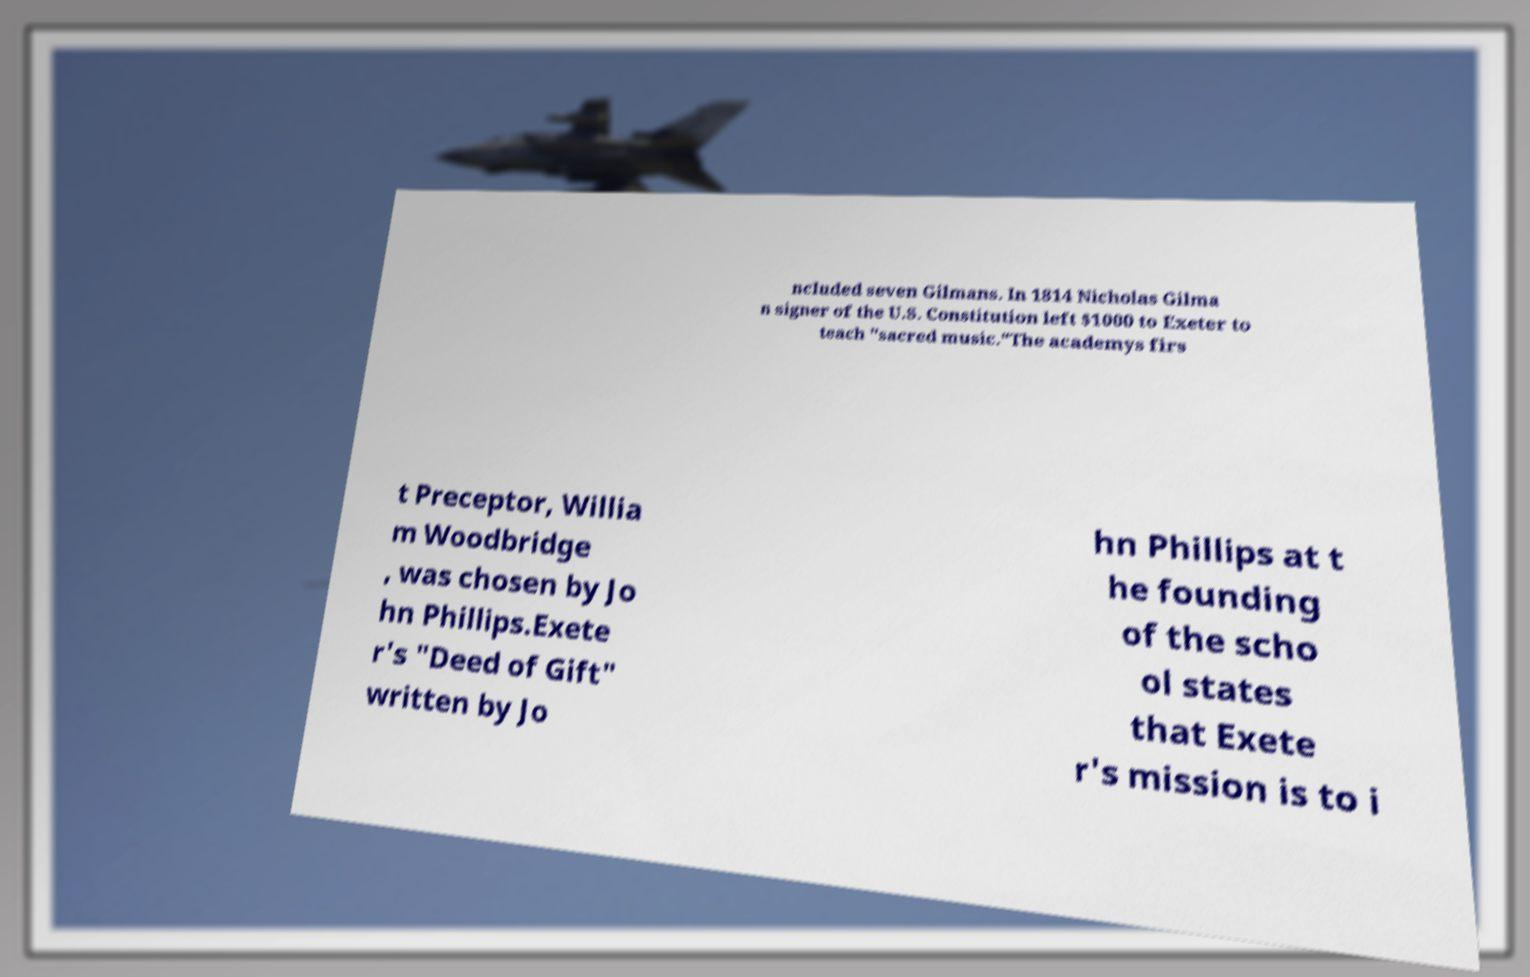There's text embedded in this image that I need extracted. Can you transcribe it verbatim? ncluded seven Gilmans. In 1814 Nicholas Gilma n signer of the U.S. Constitution left $1000 to Exeter to teach "sacred music."The academys firs t Preceptor, Willia m Woodbridge , was chosen by Jo hn Phillips.Exete r's "Deed of Gift" written by Jo hn Phillips at t he founding of the scho ol states that Exete r's mission is to i 